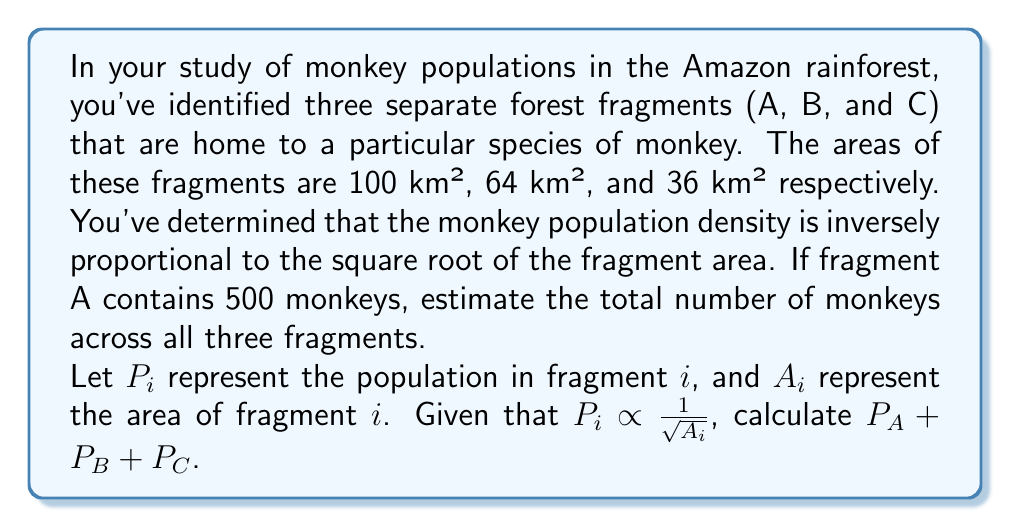Solve this math problem. To solve this problem, we'll follow these steps:

1) First, we need to establish the relationship between population and area. We're told that population density is inversely proportional to the square root of the area. This can be expressed as:

   $P_i = k \cdot \frac{1}{\sqrt{A_i}}$

   Where $k$ is a constant of proportionality.

2) We can find $k$ using the information for fragment A:

   $500 = k \cdot \frac{1}{\sqrt{100}}$
   $500 = k \cdot \frac{1}{10}$
   $k = 500 \cdot 10 = 5000$

3) Now that we have $k$, we can calculate the populations for fragments B and C:

   For B: $P_B = 5000 \cdot \frac{1}{\sqrt{64}} = 5000 \cdot \frac{1}{8} = 625$

   For C: $P_C = 5000 \cdot \frac{1}{\sqrt{36}} = 5000 \cdot \frac{1}{6} \approx 833.33$

4) The total population is the sum of the populations in all three fragments:

   $P_{total} = P_A + P_B + P_C = 500 + 625 + 833.33 = 1958.33$

5) Rounding to the nearest whole number (as we can't have a fractional monkey), we get 1958 monkeys.
Answer: The total estimated number of monkeys across all three fragments is 1958. 